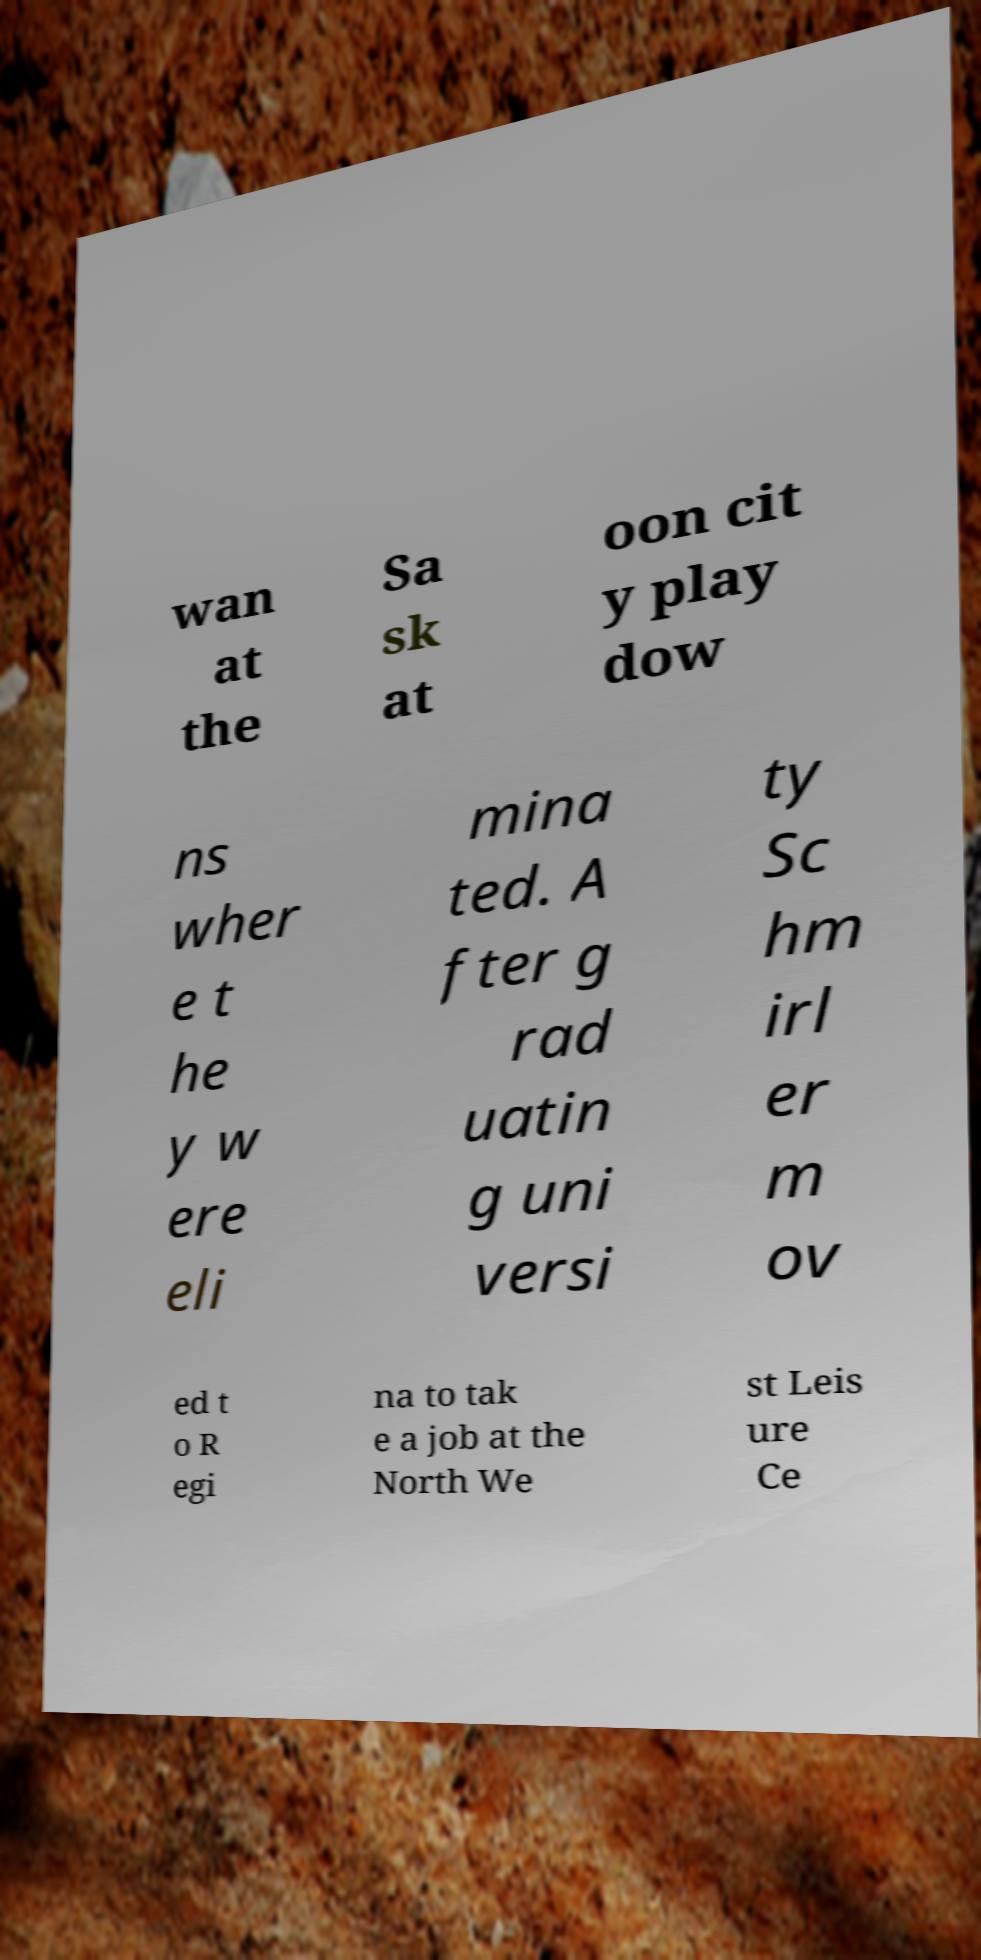I need the written content from this picture converted into text. Can you do that? wan at the Sa sk at oon cit y play dow ns wher e t he y w ere eli mina ted. A fter g rad uatin g uni versi ty Sc hm irl er m ov ed t o R egi na to tak e a job at the North We st Leis ure Ce 